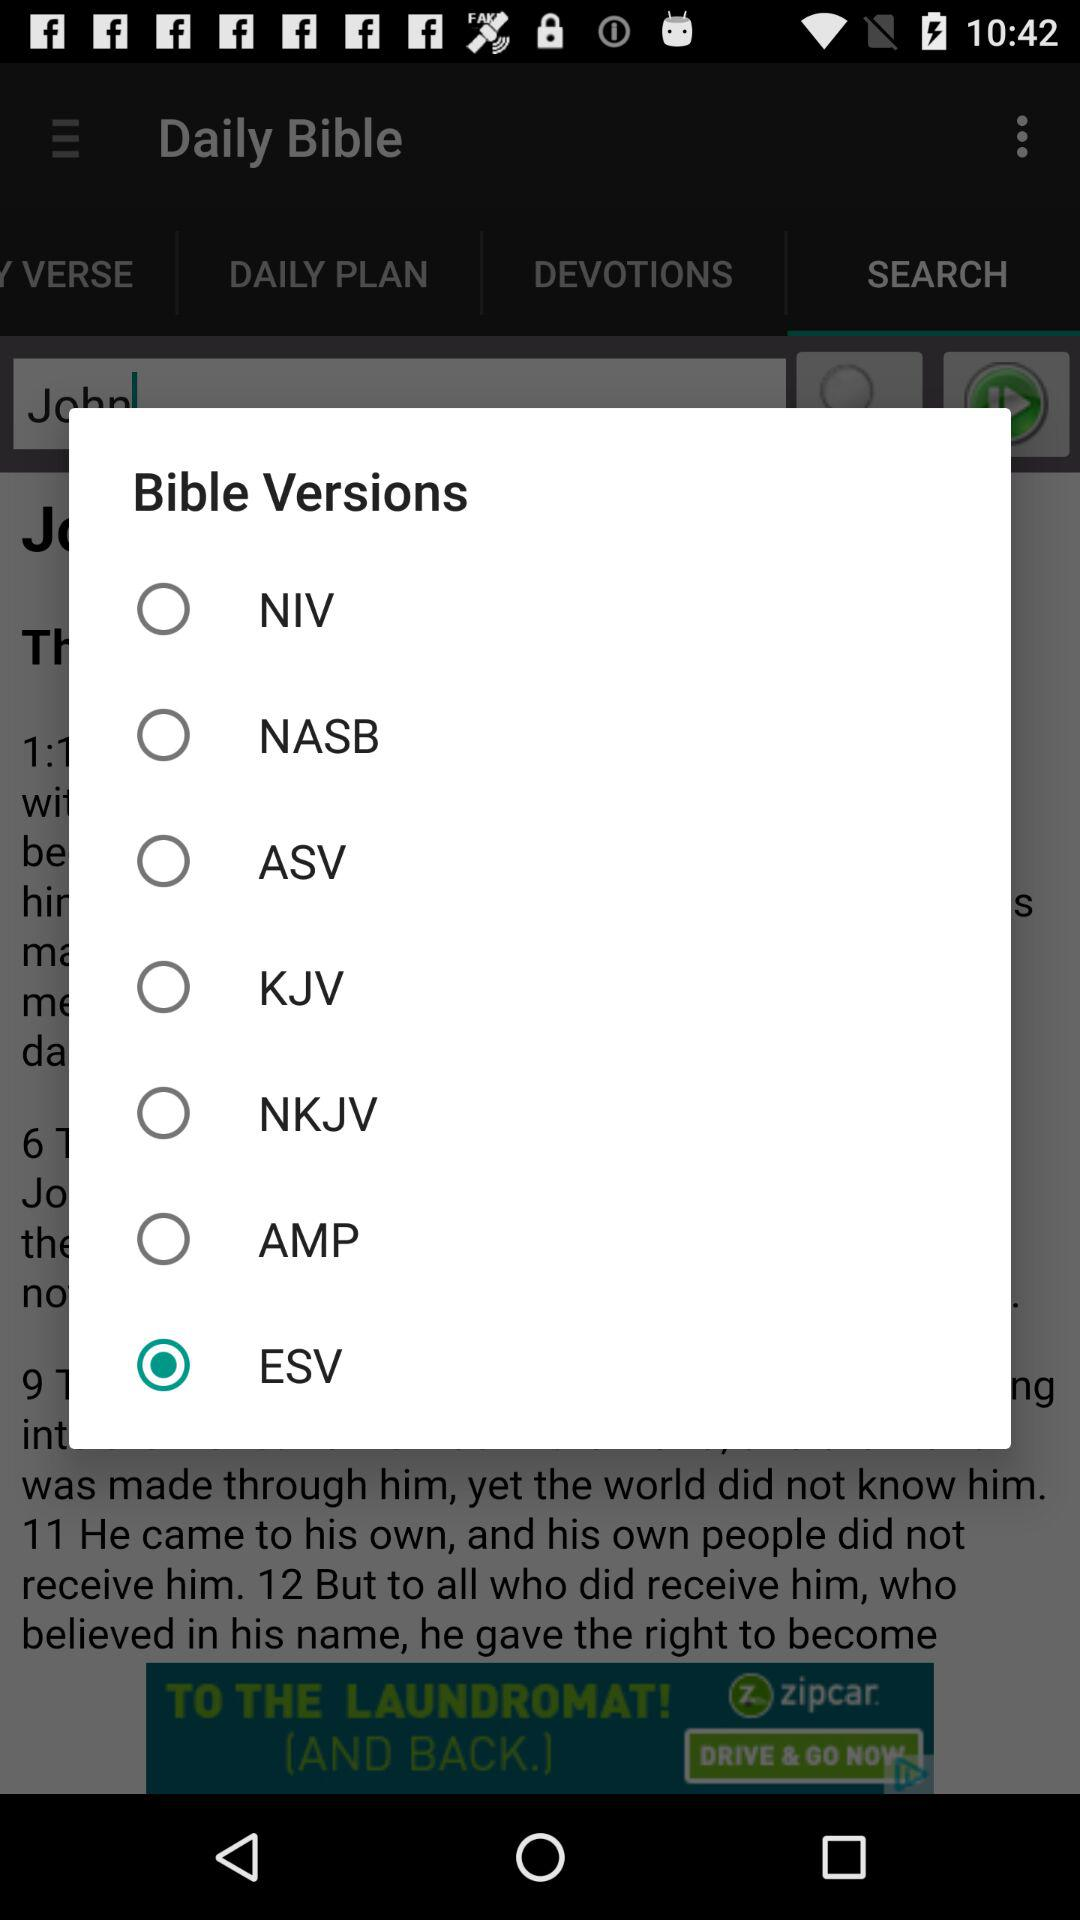How many Bible versions are available to choose from?
Answer the question using a single word or phrase. 7 